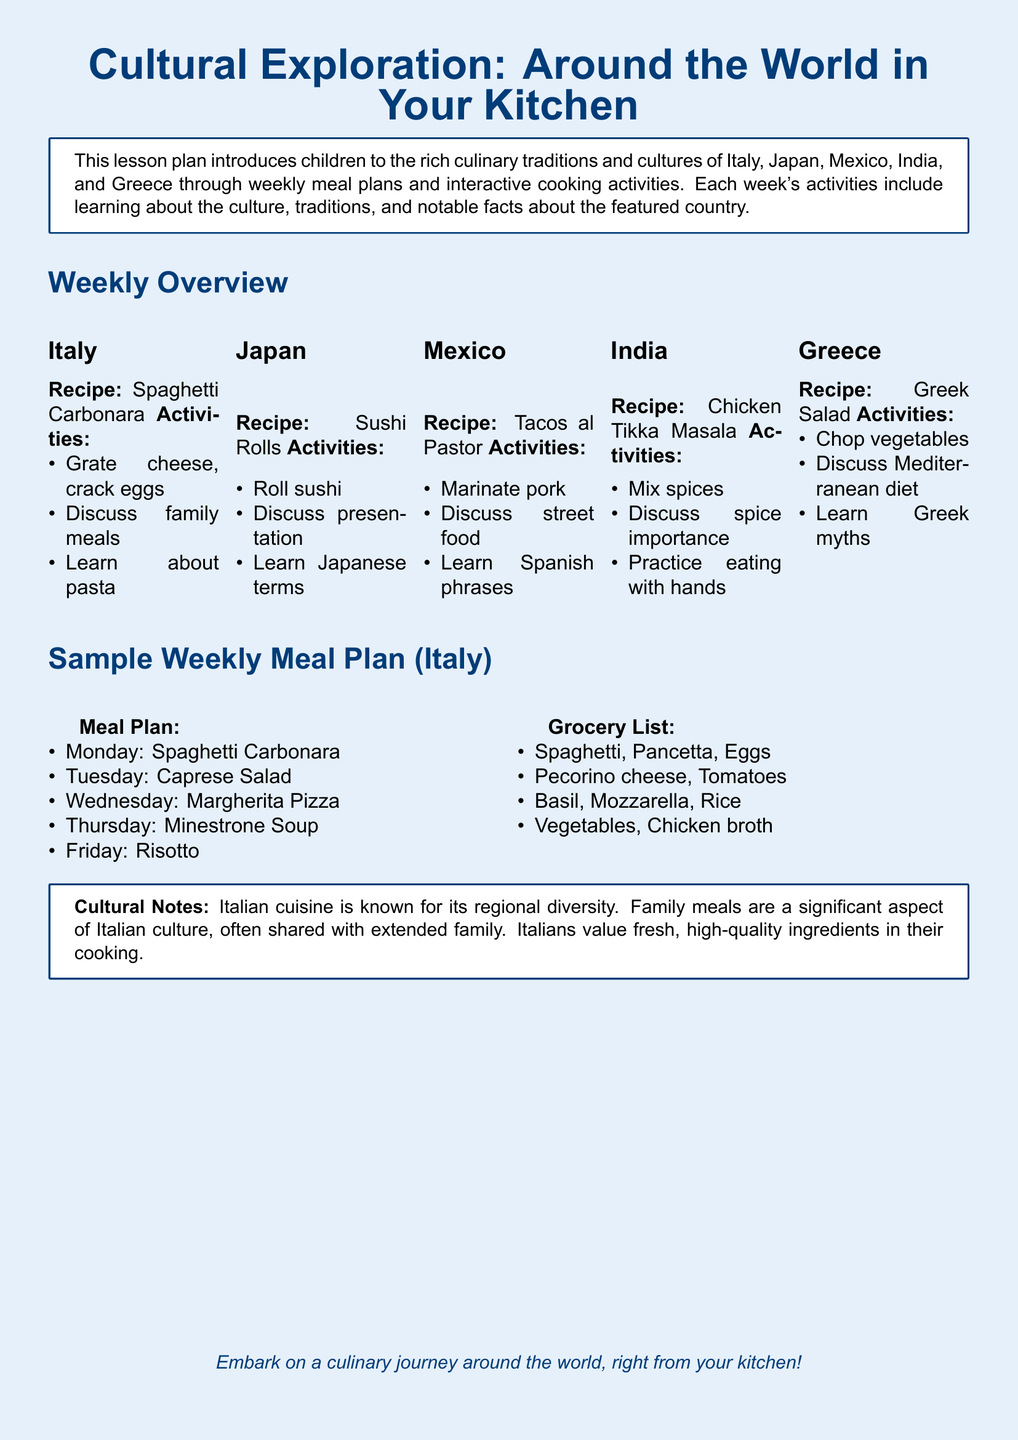What is the recipe featured for Italy? The document states that the recipe for Italy is Spaghetti Carbonara.
Answer: Spaghetti Carbonara What activities are included for making Sushi Rolls? The activities for making Sushi Rolls include rolling sushi, discussing presentation, and learning Japanese terms.
Answer: Roll sushi, discuss presentation, learn Japanese terms How many meal plans are provided for Italy? The meal plan section for Italy contains five meals, as listed in the document.
Answer: Five What dish is associated with India's culinary tradition? The document lists Chicken Tikka Masala as the dish associated with India.
Answer: Chicken Tikka Masala What is discussed regarding Mexican cuisine in the activities? The activities include discussing street food, which highlights a cultural aspect of Mexican cuisine.
Answer: Discuss street food What is the main focus of the lesson plan? The main focus of the lesson plan is to introduce children to various culinary traditions and cultures around the world.
Answer: Culinary traditions and cultures 